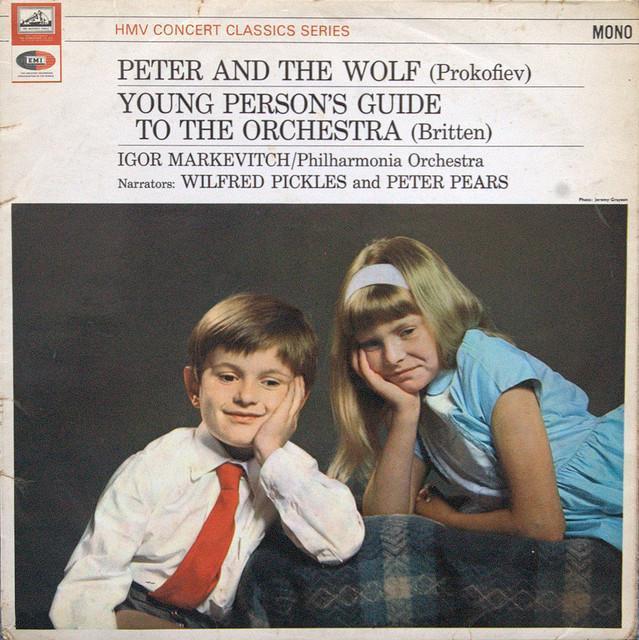How many people can you see?
Give a very brief answer. 2. How many zebras are there in the picture?
Give a very brief answer. 0. 